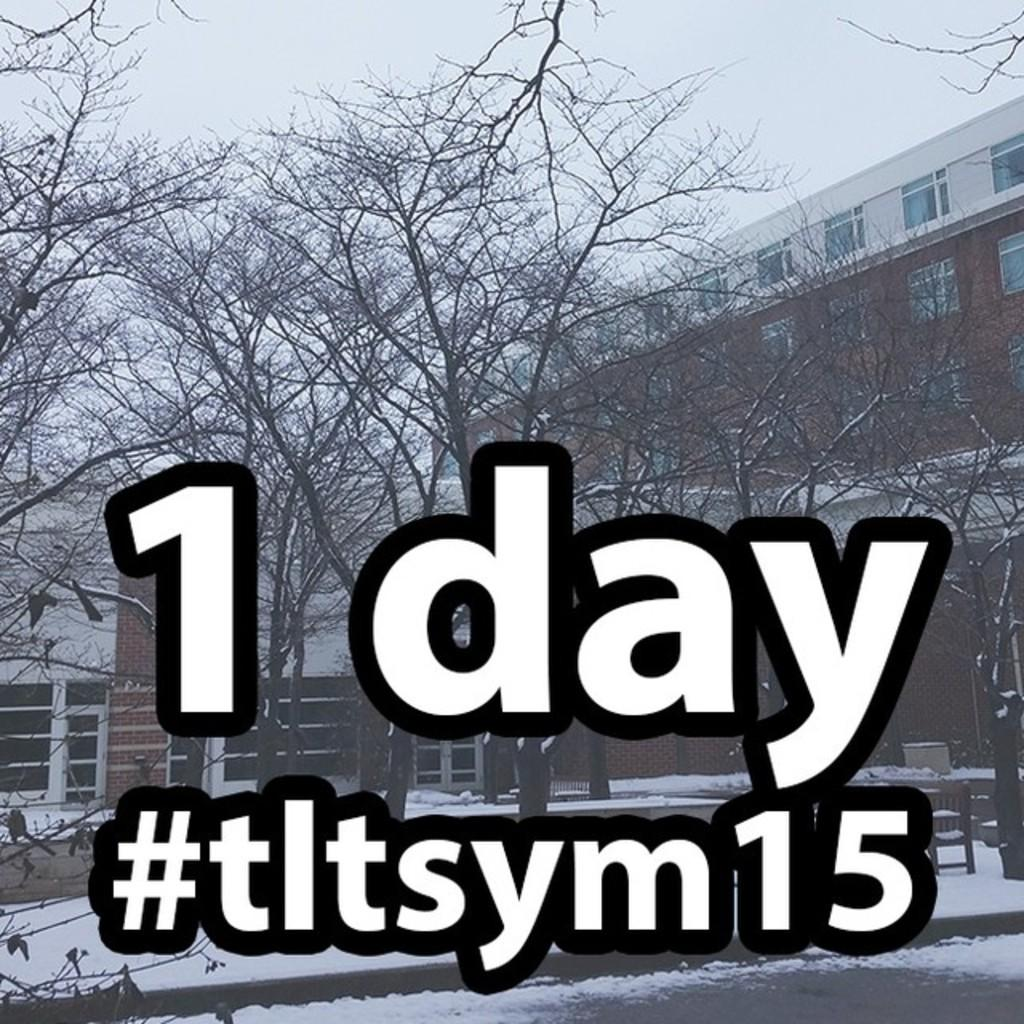What type of structures can be seen in the image? There are buildings in the image. What other natural elements are present in the image? There are trees in the image. What part of the buildings can be seen in the image? There are windows visible in the image. What is the weather like in the image? There is snow in the image, indicating a cold or wintery environment. What is visible in the background of the image? The sky is visible in the image. Are there any written words or symbols in the image? Yes, there is text present in the image. Where is the cobweb located in the image? There is no cobweb present in the image. What type of food is being served in the lunchroom in the image? There is no lunchroom present in the image. 